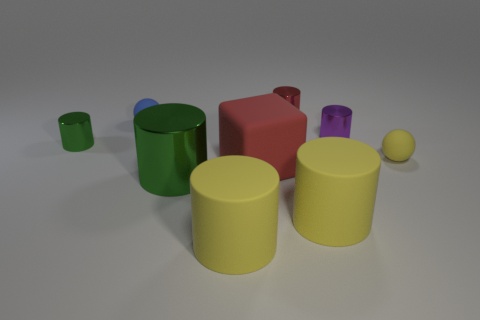What number of objects are red matte cubes or purple metallic cylinders?
Your answer should be compact. 2. Are any red metal objects visible?
Your answer should be very brief. Yes. The large yellow object that is behind the yellow thing that is on the left side of the small red cylinder is what shape?
Keep it short and to the point. Cylinder. What number of things are red things in front of the small red cylinder or large cylinders that are on the right side of the big green cylinder?
Your answer should be very brief. 3. There is a green object that is the same size as the yellow matte ball; what is its material?
Keep it short and to the point. Metal. What is the color of the large shiny cylinder?
Your response must be concise. Green. What is the object that is to the right of the red cylinder and in front of the small yellow rubber thing made of?
Offer a terse response. Rubber. Are there any red shiny cylinders that are on the right side of the small ball that is to the right of the tiny matte thing on the left side of the yellow matte ball?
Your answer should be very brief. No. The shiny thing that is the same color as the big metallic cylinder is what size?
Your answer should be compact. Small. There is a small blue thing; are there any red blocks behind it?
Your answer should be very brief. No. 